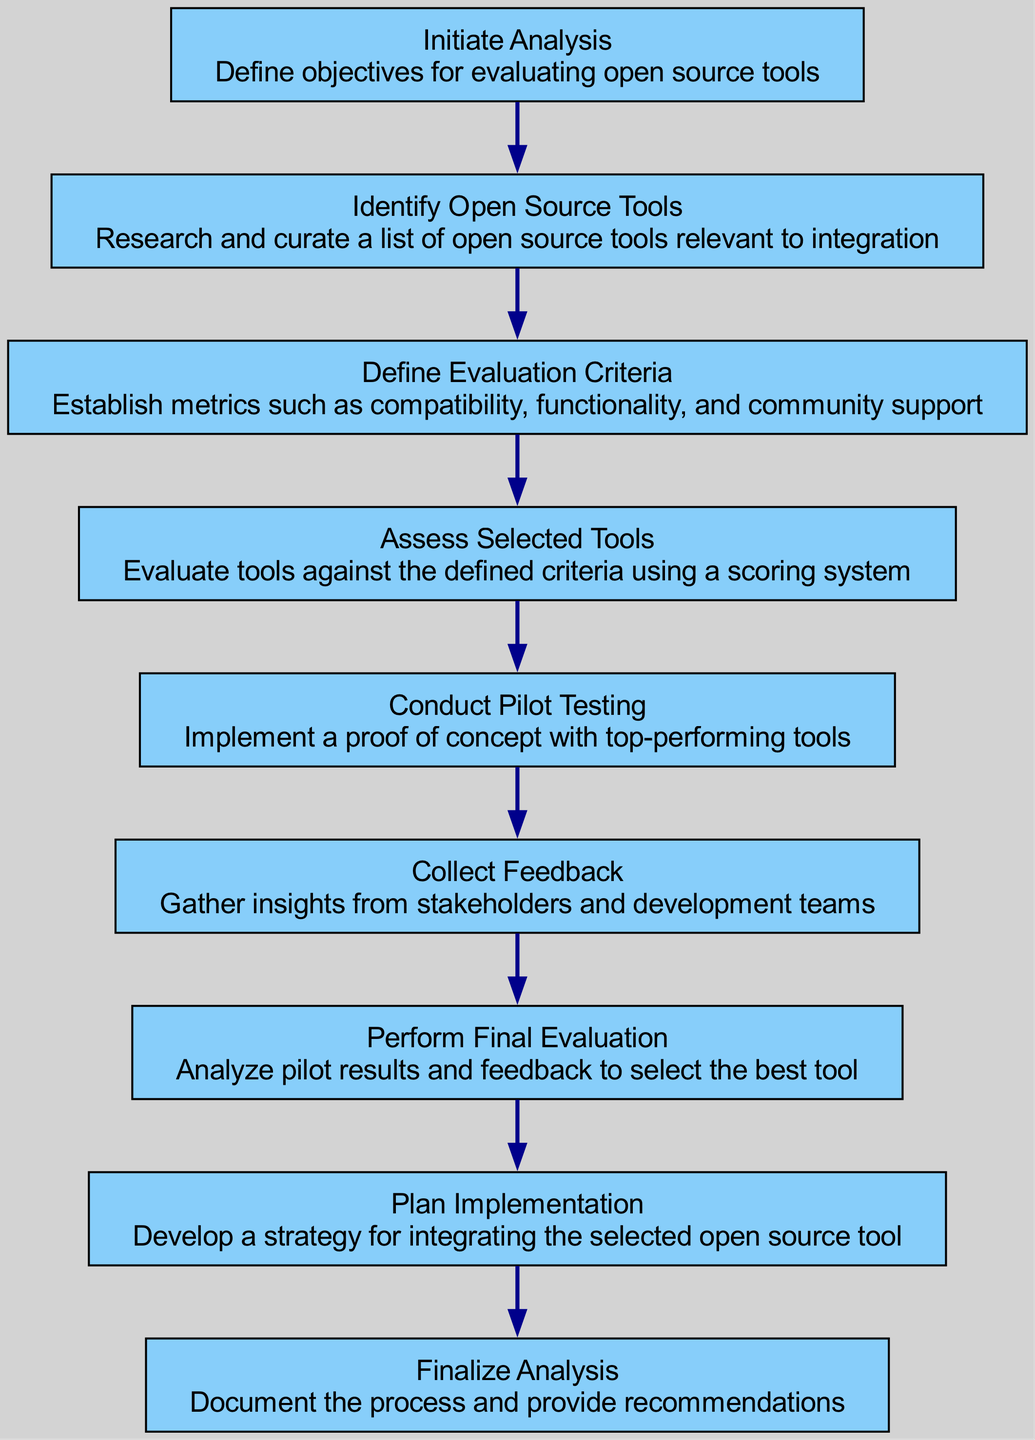What is the first step in the analysis workflow? The first step in the workflow is labeled as "Initiate Analysis". It starts the process of evaluating open source tools.
Answer: Initiate Analysis How many processes are there in total? The diagram includes a total of 8 distinct processes, starting from "Initiate Analysis" and ending with "Finalize Analysis".
Answer: 8 Which process comes after "Collect Feedback"? The process that follows "Collect Feedback" is "Perform Final Evaluation". This is indicated by a direct connection from the former to the latter in the diagram.
Answer: Perform Final Evaluation What criteria are established for the evaluation of tools? The diagram specifies that the criteria for evaluation are defined in the "Define Evaluation Criteria" process, where metrics such as compatibility, functionality, and community support are established.
Answer: Compatibility, functionality, and community support Is there a direct link from "Assess Selected Tools" to "Collect Feedback"? No, there is no direct link between "Assess Selected Tools" and "Collect Feedback". The workflow follows a sequence where after assessing tools, the next step is "Conduct Pilot Testing".
Answer: No What is the final process in the workflow? The final process in the diagram concludes with "Finalize Analysis". This indicates the completion of the entire evaluation process by documenting the results.
Answer: Finalize Analysis How do you gather insights during the analysis workflow? Insights are gathered in the "Collect Feedback" process, where feedback from stakeholders and development teams is actively sought.
Answer: Collect Feedback Which process requires implementing a proof of concept? The "Conduct Pilot Testing" process is where a proof of concept is implemented with the top-performing tools identified during the assessment phase.
Answer: Conduct Pilot Testing 